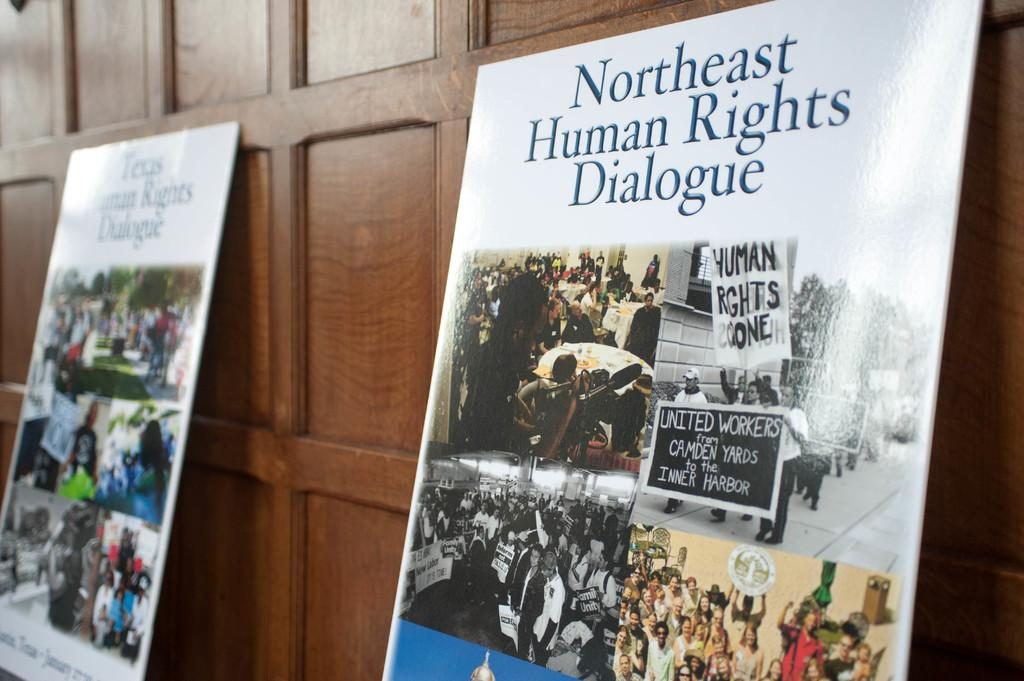<image>
Write a terse but informative summary of the picture. A poster with Human Rights pictures on them with the words Northeast Human Rights Dialogoue. 